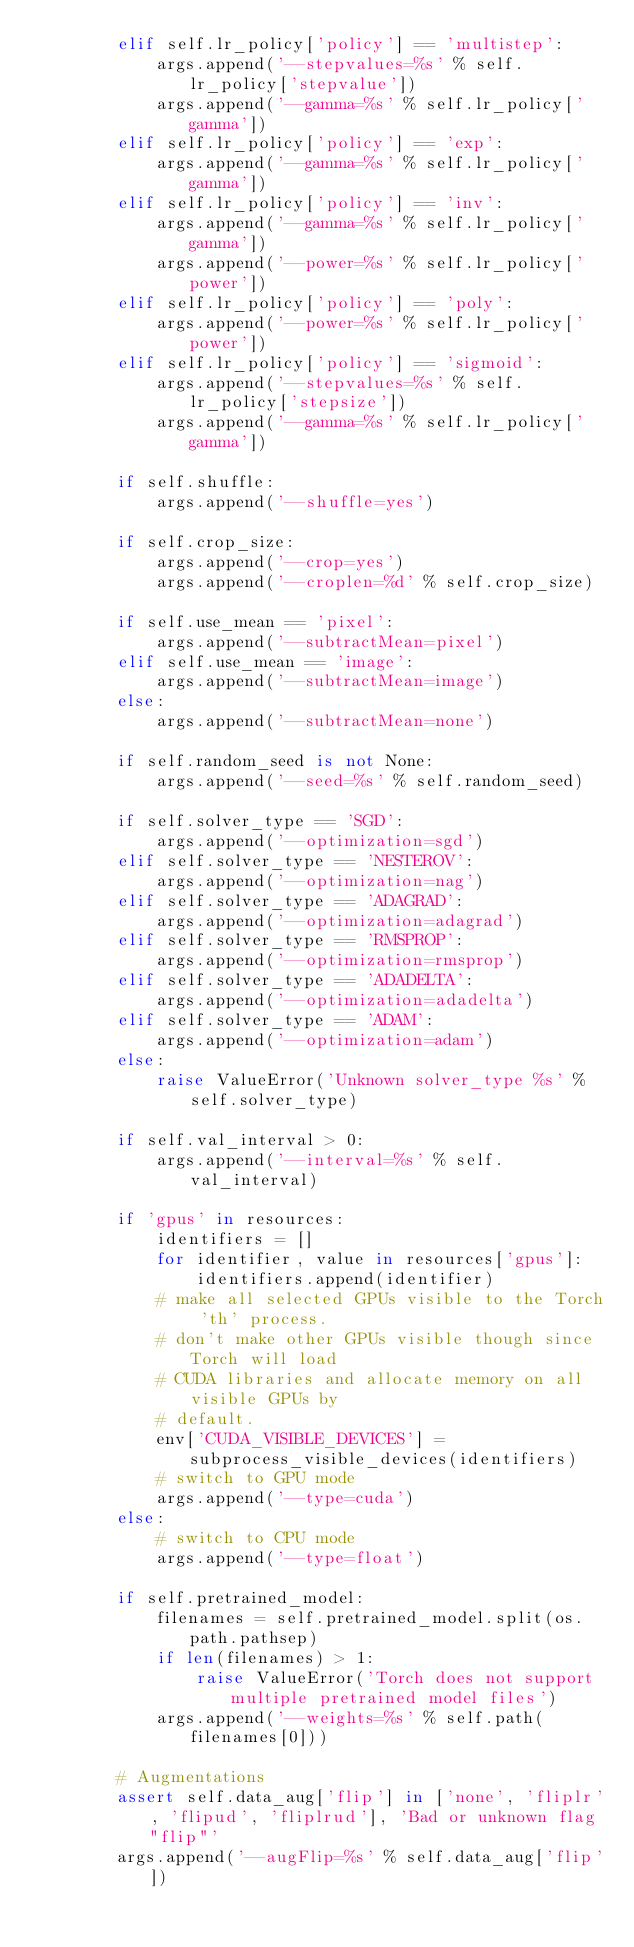Convert code to text. <code><loc_0><loc_0><loc_500><loc_500><_Python_>        elif self.lr_policy['policy'] == 'multistep':
            args.append('--stepvalues=%s' % self.lr_policy['stepvalue'])
            args.append('--gamma=%s' % self.lr_policy['gamma'])
        elif self.lr_policy['policy'] == 'exp':
            args.append('--gamma=%s' % self.lr_policy['gamma'])
        elif self.lr_policy['policy'] == 'inv':
            args.append('--gamma=%s' % self.lr_policy['gamma'])
            args.append('--power=%s' % self.lr_policy['power'])
        elif self.lr_policy['policy'] == 'poly':
            args.append('--power=%s' % self.lr_policy['power'])
        elif self.lr_policy['policy'] == 'sigmoid':
            args.append('--stepvalues=%s' % self.lr_policy['stepsize'])
            args.append('--gamma=%s' % self.lr_policy['gamma'])

        if self.shuffle:
            args.append('--shuffle=yes')

        if self.crop_size:
            args.append('--crop=yes')
            args.append('--croplen=%d' % self.crop_size)

        if self.use_mean == 'pixel':
            args.append('--subtractMean=pixel')
        elif self.use_mean == 'image':
            args.append('--subtractMean=image')
        else:
            args.append('--subtractMean=none')

        if self.random_seed is not None:
            args.append('--seed=%s' % self.random_seed)

        if self.solver_type == 'SGD':
            args.append('--optimization=sgd')
        elif self.solver_type == 'NESTEROV':
            args.append('--optimization=nag')
        elif self.solver_type == 'ADAGRAD':
            args.append('--optimization=adagrad')
        elif self.solver_type == 'RMSPROP':
            args.append('--optimization=rmsprop')
        elif self.solver_type == 'ADADELTA':
            args.append('--optimization=adadelta')
        elif self.solver_type == 'ADAM':
            args.append('--optimization=adam')
        else:
            raise ValueError('Unknown solver_type %s' % self.solver_type)

        if self.val_interval > 0:
            args.append('--interval=%s' % self.val_interval)

        if 'gpus' in resources:
            identifiers = []
            for identifier, value in resources['gpus']:
                identifiers.append(identifier)
            # make all selected GPUs visible to the Torch 'th' process.
            # don't make other GPUs visible though since Torch will load
            # CUDA libraries and allocate memory on all visible GPUs by
            # default.
            env['CUDA_VISIBLE_DEVICES'] = subprocess_visible_devices(identifiers)
            # switch to GPU mode
            args.append('--type=cuda')
        else:
            # switch to CPU mode
            args.append('--type=float')

        if self.pretrained_model:
            filenames = self.pretrained_model.split(os.path.pathsep)
            if len(filenames) > 1:
                raise ValueError('Torch does not support multiple pretrained model files')
            args.append('--weights=%s' % self.path(filenames[0]))

        # Augmentations
        assert self.data_aug['flip'] in ['none', 'fliplr', 'flipud', 'fliplrud'], 'Bad or unknown flag "flip"'
        args.append('--augFlip=%s' % self.data_aug['flip'])
</code> 